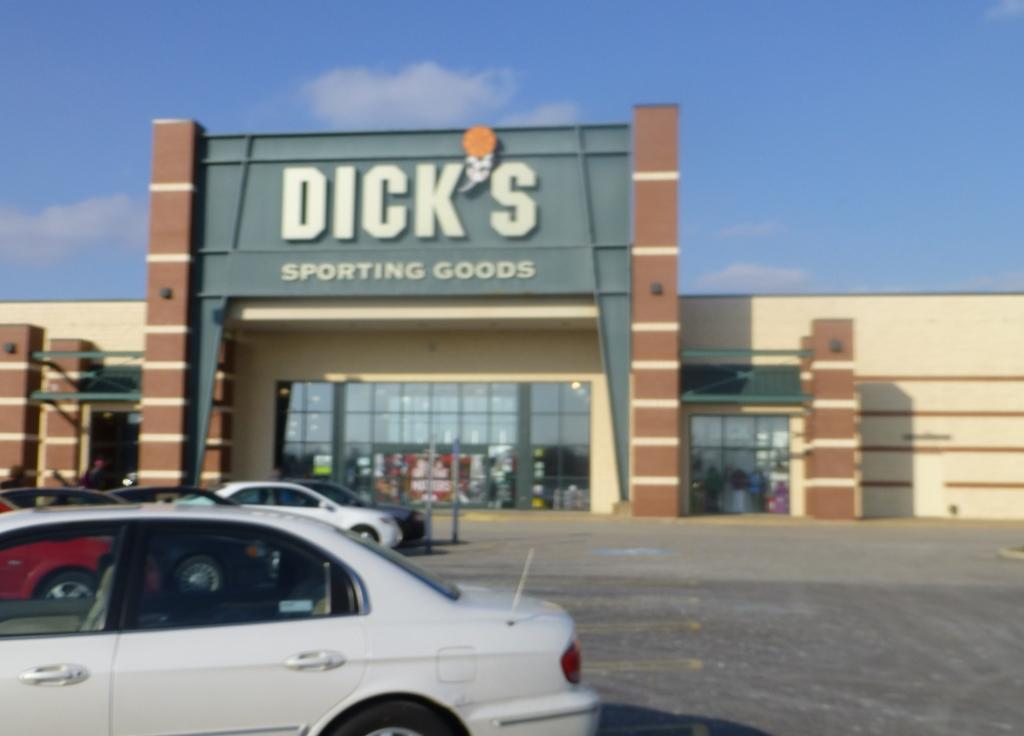What can be seen on the left side of the image? There are vehicles on the road on the left side of the image. What is visible in the background of the image? There is a building in the background of the image. What features can be observed on the building? The building has windows and a hoarding. What is visible in the sky in the image? There are clouds in the sky. How much do the dolls weigh in the image? There are no dolls present in the image, so their weight cannot be determined. What type of care is being provided to the vehicles in the image? There is no indication of any care being provided to the vehicles in the image; they are simply driving on the road. 